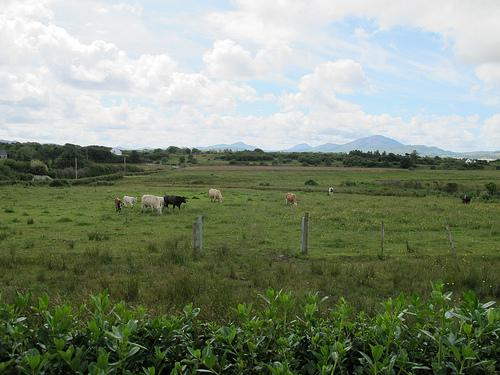Question: why is there a fence surrounding the field?
Choices:
A. The look pretty.
B. To keep the squirrels out.
C. To please the animals.
D. To keep the cows from escaping.
Answer with the letter. Answer: D Question: where is this picture taken?
Choices:
A. At a party.
B. On a field.
C. At a concert.
D. On a boat.
Answer with the letter. Answer: B Question: when will the cows raise up their heads?
Choices:
A. When someone approaches.
B. When the calf cries.
C. When they are through eating the grass.
D. When the dog chases them.
Answer with the letter. Answer: C 